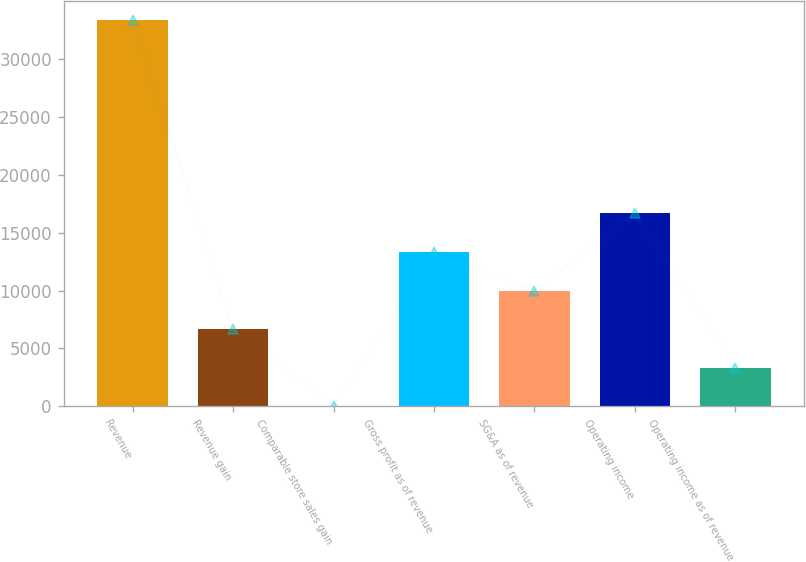Convert chart. <chart><loc_0><loc_0><loc_500><loc_500><bar_chart><fcel>Revenue<fcel>Revenue gain<fcel>Comparable store sales gain<fcel>Gross profit as of revenue<fcel>SG&A as of revenue<fcel>Operating income<fcel>Operating income as of revenue<nl><fcel>33328<fcel>6667.12<fcel>1.9<fcel>13332.3<fcel>9999.73<fcel>16665<fcel>3334.51<nl></chart> 